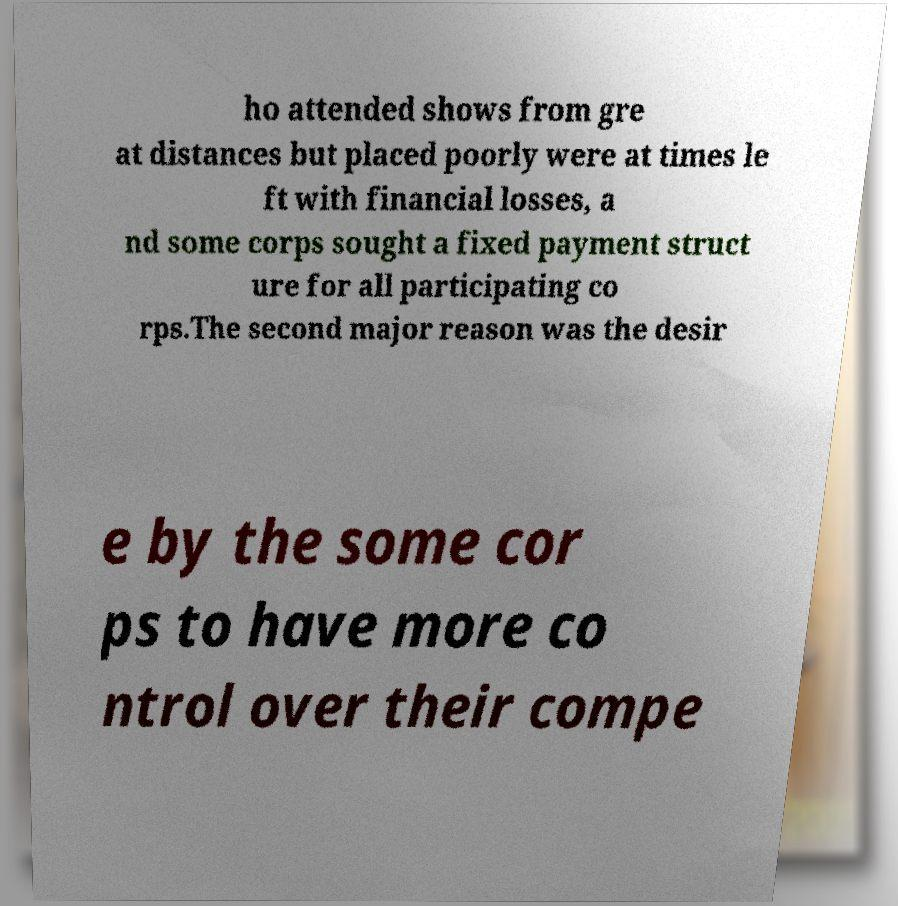Please identify and transcribe the text found in this image. ho attended shows from gre at distances but placed poorly were at times le ft with financial losses, a nd some corps sought a fixed payment struct ure for all participating co rps.The second major reason was the desir e by the some cor ps to have more co ntrol over their compe 